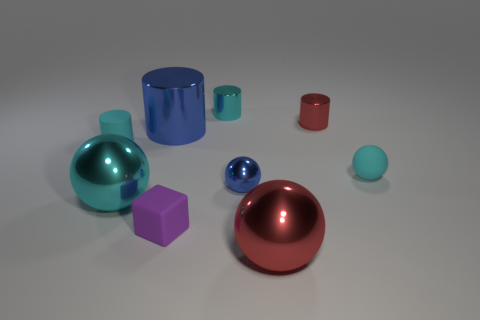There is a metallic object that is the same color as the small metallic ball; what shape is it?
Your response must be concise. Cylinder. Are there more large cyan balls to the right of the small rubber ball than big cyan spheres that are left of the cyan metal sphere?
Offer a very short reply. No. What is the material of the red object behind the metal sphere left of the metallic sphere that is behind the cyan metal sphere?
Make the answer very short. Metal. There is a tiny blue object that is the same material as the large red object; what is its shape?
Ensure brevity in your answer.  Sphere. There is a metal cylinder that is in front of the red cylinder; are there any blue objects on the right side of it?
Ensure brevity in your answer.  Yes. What size is the purple matte object?
Your response must be concise. Small. What number of objects are large red things or large cyan spheres?
Provide a succinct answer. 2. Is the cyan object in front of the small blue metallic sphere made of the same material as the red object behind the red sphere?
Provide a short and direct response. Yes. What is the color of the ball that is made of the same material as the tiny purple thing?
Offer a very short reply. Cyan. What number of blue spheres are the same size as the red metal ball?
Your answer should be compact. 0. 